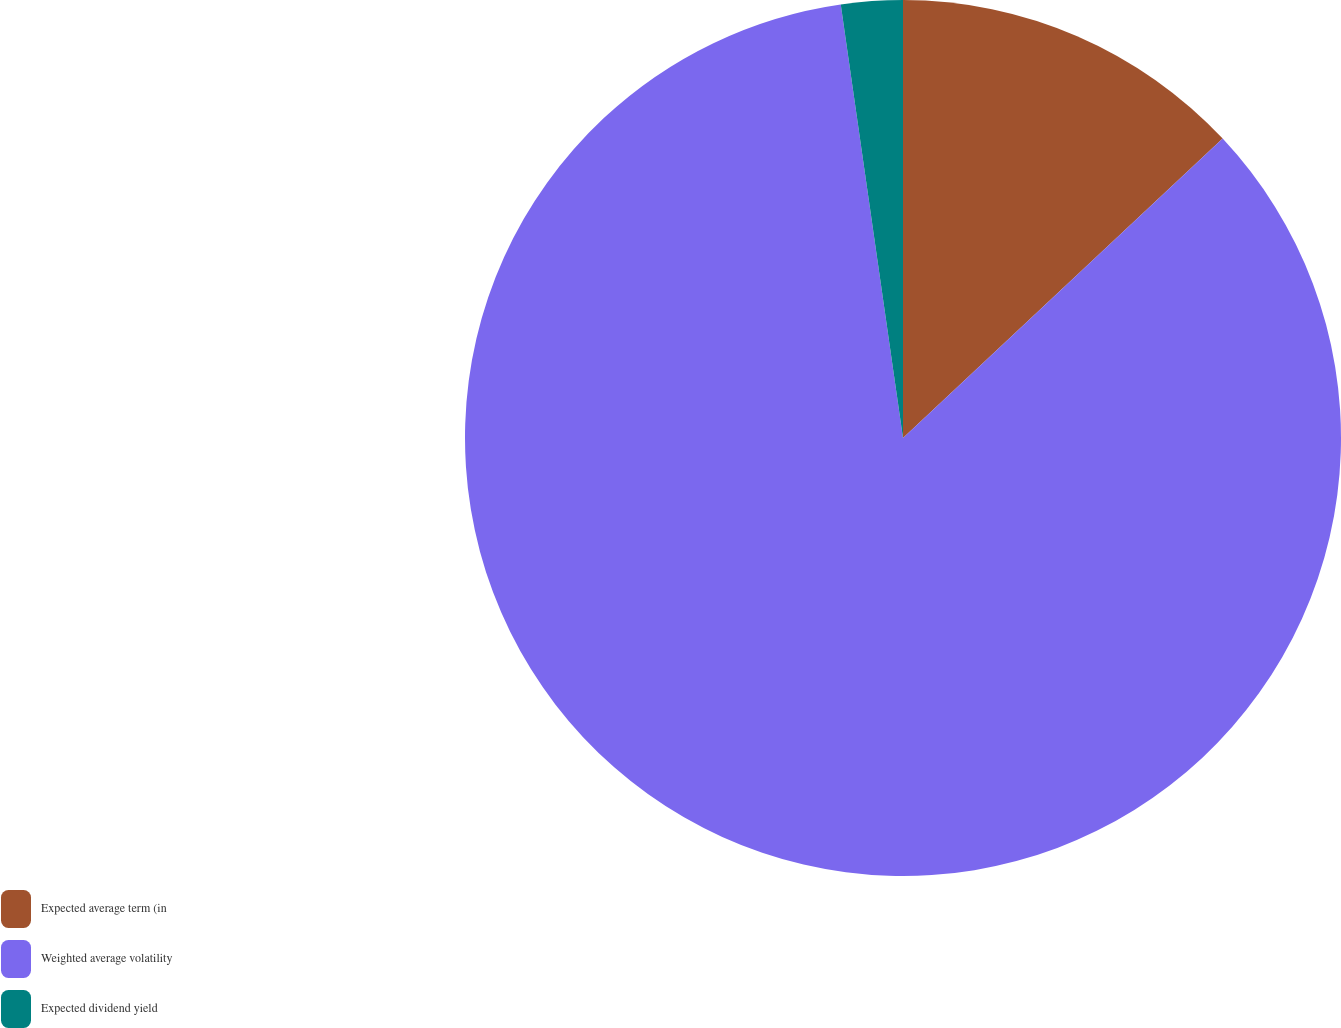Convert chart to OTSL. <chart><loc_0><loc_0><loc_500><loc_500><pie_chart><fcel>Expected average term (in<fcel>Weighted average volatility<fcel>Expected dividend yield<nl><fcel>13.02%<fcel>84.71%<fcel>2.27%<nl></chart> 